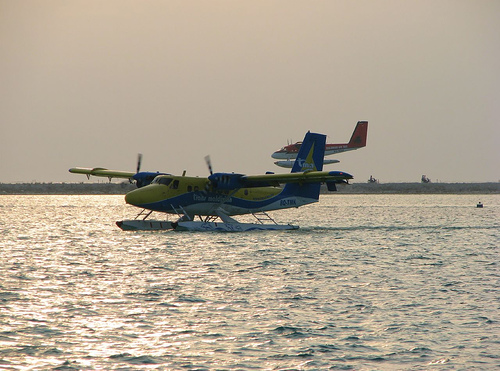<image>
Can you confirm if the airplane is on the water? Yes. Looking at the image, I can see the airplane is positioned on top of the water, with the water providing support. 